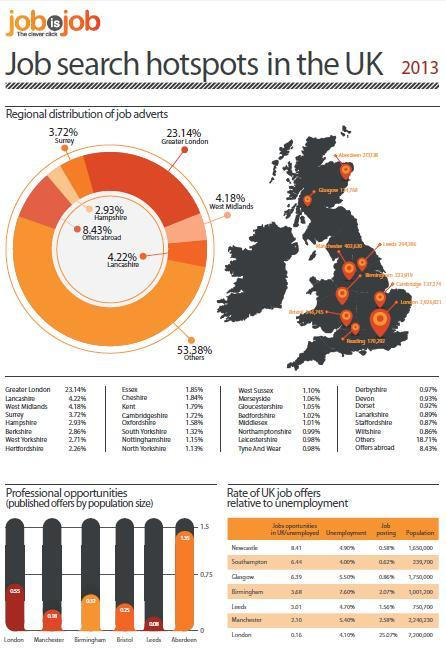What is the percentage of job adverts in surrey in 2013?
Answer the question with a short phrase. 3.72% What is the percentage of job adverts in West Midlands in 2013? 4.18% Which county in England has the highest percentage of job adverts in 2013? Greater London Which county in England has the second highest percentage of job adverts in 2013? Lancashire 